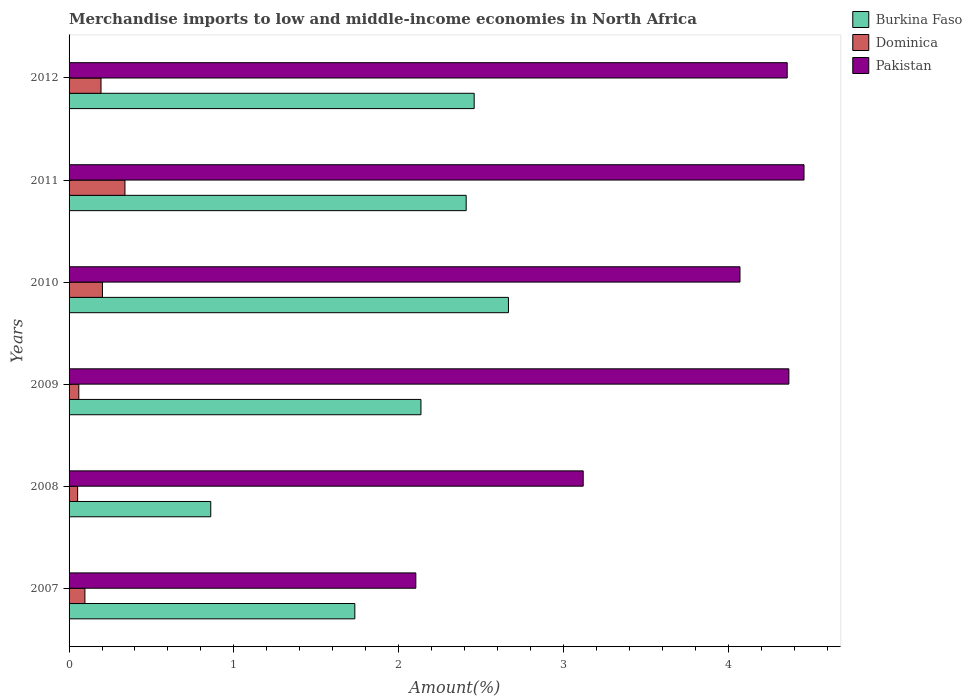How many different coloured bars are there?
Offer a terse response. 3. How many groups of bars are there?
Your answer should be compact. 6. Are the number of bars on each tick of the Y-axis equal?
Provide a succinct answer. Yes. What is the percentage of amount earned from merchandise imports in Pakistan in 2010?
Your response must be concise. 4.07. Across all years, what is the maximum percentage of amount earned from merchandise imports in Pakistan?
Provide a succinct answer. 4.46. Across all years, what is the minimum percentage of amount earned from merchandise imports in Burkina Faso?
Ensure brevity in your answer.  0.86. In which year was the percentage of amount earned from merchandise imports in Burkina Faso maximum?
Provide a succinct answer. 2010. In which year was the percentage of amount earned from merchandise imports in Burkina Faso minimum?
Provide a succinct answer. 2008. What is the total percentage of amount earned from merchandise imports in Burkina Faso in the graph?
Offer a very short reply. 12.26. What is the difference between the percentage of amount earned from merchandise imports in Pakistan in 2011 and that in 2012?
Provide a succinct answer. 0.1. What is the difference between the percentage of amount earned from merchandise imports in Burkina Faso in 2009 and the percentage of amount earned from merchandise imports in Pakistan in 2011?
Offer a very short reply. -2.32. What is the average percentage of amount earned from merchandise imports in Dominica per year?
Give a very brief answer. 0.16. In the year 2009, what is the difference between the percentage of amount earned from merchandise imports in Pakistan and percentage of amount earned from merchandise imports in Burkina Faso?
Make the answer very short. 2.23. In how many years, is the percentage of amount earned from merchandise imports in Dominica greater than 3.8 %?
Offer a terse response. 0. What is the ratio of the percentage of amount earned from merchandise imports in Dominica in 2008 to that in 2009?
Your response must be concise. 0.88. Is the difference between the percentage of amount earned from merchandise imports in Pakistan in 2008 and 2012 greater than the difference between the percentage of amount earned from merchandise imports in Burkina Faso in 2008 and 2012?
Keep it short and to the point. Yes. What is the difference between the highest and the second highest percentage of amount earned from merchandise imports in Burkina Faso?
Ensure brevity in your answer.  0.21. What is the difference between the highest and the lowest percentage of amount earned from merchandise imports in Dominica?
Give a very brief answer. 0.29. What does the 3rd bar from the top in 2007 represents?
Make the answer very short. Burkina Faso. How many bars are there?
Offer a very short reply. 18. Does the graph contain grids?
Your answer should be very brief. No. How many legend labels are there?
Provide a succinct answer. 3. How are the legend labels stacked?
Provide a short and direct response. Vertical. What is the title of the graph?
Ensure brevity in your answer.  Merchandise imports to low and middle-income economies in North Africa. What is the label or title of the X-axis?
Provide a short and direct response. Amount(%). What is the label or title of the Y-axis?
Offer a terse response. Years. What is the Amount(%) in Burkina Faso in 2007?
Ensure brevity in your answer.  1.73. What is the Amount(%) in Dominica in 2007?
Keep it short and to the point. 0.1. What is the Amount(%) in Pakistan in 2007?
Keep it short and to the point. 2.1. What is the Amount(%) in Burkina Faso in 2008?
Your answer should be very brief. 0.86. What is the Amount(%) of Dominica in 2008?
Provide a short and direct response. 0.05. What is the Amount(%) in Pakistan in 2008?
Give a very brief answer. 3.12. What is the Amount(%) of Burkina Faso in 2009?
Give a very brief answer. 2.14. What is the Amount(%) of Dominica in 2009?
Your response must be concise. 0.06. What is the Amount(%) in Pakistan in 2009?
Give a very brief answer. 4.37. What is the Amount(%) in Burkina Faso in 2010?
Keep it short and to the point. 2.67. What is the Amount(%) of Dominica in 2010?
Keep it short and to the point. 0.2. What is the Amount(%) of Pakistan in 2010?
Offer a very short reply. 4.07. What is the Amount(%) of Burkina Faso in 2011?
Offer a terse response. 2.41. What is the Amount(%) of Dominica in 2011?
Provide a succinct answer. 0.34. What is the Amount(%) in Pakistan in 2011?
Make the answer very short. 4.46. What is the Amount(%) in Burkina Faso in 2012?
Provide a succinct answer. 2.46. What is the Amount(%) of Dominica in 2012?
Ensure brevity in your answer.  0.19. What is the Amount(%) in Pakistan in 2012?
Provide a succinct answer. 4.36. Across all years, what is the maximum Amount(%) in Burkina Faso?
Provide a short and direct response. 2.67. Across all years, what is the maximum Amount(%) in Dominica?
Give a very brief answer. 0.34. Across all years, what is the maximum Amount(%) in Pakistan?
Give a very brief answer. 4.46. Across all years, what is the minimum Amount(%) in Burkina Faso?
Make the answer very short. 0.86. Across all years, what is the minimum Amount(%) in Dominica?
Your response must be concise. 0.05. Across all years, what is the minimum Amount(%) of Pakistan?
Provide a short and direct response. 2.1. What is the total Amount(%) in Burkina Faso in the graph?
Offer a terse response. 12.26. What is the total Amount(%) in Dominica in the graph?
Keep it short and to the point. 0.94. What is the total Amount(%) in Pakistan in the graph?
Your answer should be very brief. 22.48. What is the difference between the Amount(%) in Burkina Faso in 2007 and that in 2008?
Your response must be concise. 0.87. What is the difference between the Amount(%) in Dominica in 2007 and that in 2008?
Offer a terse response. 0.04. What is the difference between the Amount(%) of Pakistan in 2007 and that in 2008?
Your answer should be very brief. -1.02. What is the difference between the Amount(%) of Burkina Faso in 2007 and that in 2009?
Give a very brief answer. -0.4. What is the difference between the Amount(%) of Dominica in 2007 and that in 2009?
Your answer should be compact. 0.04. What is the difference between the Amount(%) in Pakistan in 2007 and that in 2009?
Your answer should be very brief. -2.26. What is the difference between the Amount(%) of Burkina Faso in 2007 and that in 2010?
Your answer should be compact. -0.93. What is the difference between the Amount(%) of Dominica in 2007 and that in 2010?
Provide a short and direct response. -0.11. What is the difference between the Amount(%) of Pakistan in 2007 and that in 2010?
Your response must be concise. -1.97. What is the difference between the Amount(%) of Burkina Faso in 2007 and that in 2011?
Your answer should be very brief. -0.68. What is the difference between the Amount(%) of Dominica in 2007 and that in 2011?
Your answer should be compact. -0.24. What is the difference between the Amount(%) in Pakistan in 2007 and that in 2011?
Make the answer very short. -2.36. What is the difference between the Amount(%) in Burkina Faso in 2007 and that in 2012?
Your answer should be very brief. -0.72. What is the difference between the Amount(%) of Dominica in 2007 and that in 2012?
Your response must be concise. -0.1. What is the difference between the Amount(%) in Pakistan in 2007 and that in 2012?
Provide a succinct answer. -2.25. What is the difference between the Amount(%) in Burkina Faso in 2008 and that in 2009?
Your answer should be compact. -1.28. What is the difference between the Amount(%) of Dominica in 2008 and that in 2009?
Your answer should be very brief. -0.01. What is the difference between the Amount(%) of Pakistan in 2008 and that in 2009?
Keep it short and to the point. -1.25. What is the difference between the Amount(%) in Burkina Faso in 2008 and that in 2010?
Offer a terse response. -1.81. What is the difference between the Amount(%) of Dominica in 2008 and that in 2010?
Provide a short and direct response. -0.15. What is the difference between the Amount(%) in Pakistan in 2008 and that in 2010?
Your answer should be compact. -0.95. What is the difference between the Amount(%) of Burkina Faso in 2008 and that in 2011?
Ensure brevity in your answer.  -1.55. What is the difference between the Amount(%) of Dominica in 2008 and that in 2011?
Give a very brief answer. -0.29. What is the difference between the Amount(%) of Pakistan in 2008 and that in 2011?
Your response must be concise. -1.34. What is the difference between the Amount(%) in Burkina Faso in 2008 and that in 2012?
Provide a succinct answer. -1.6. What is the difference between the Amount(%) of Dominica in 2008 and that in 2012?
Provide a short and direct response. -0.14. What is the difference between the Amount(%) of Pakistan in 2008 and that in 2012?
Your answer should be compact. -1.24. What is the difference between the Amount(%) of Burkina Faso in 2009 and that in 2010?
Your answer should be very brief. -0.53. What is the difference between the Amount(%) of Dominica in 2009 and that in 2010?
Provide a short and direct response. -0.14. What is the difference between the Amount(%) of Pakistan in 2009 and that in 2010?
Your response must be concise. 0.3. What is the difference between the Amount(%) in Burkina Faso in 2009 and that in 2011?
Your response must be concise. -0.27. What is the difference between the Amount(%) in Dominica in 2009 and that in 2011?
Provide a succinct answer. -0.28. What is the difference between the Amount(%) in Pakistan in 2009 and that in 2011?
Keep it short and to the point. -0.09. What is the difference between the Amount(%) of Burkina Faso in 2009 and that in 2012?
Provide a short and direct response. -0.32. What is the difference between the Amount(%) in Dominica in 2009 and that in 2012?
Give a very brief answer. -0.13. What is the difference between the Amount(%) of Pakistan in 2009 and that in 2012?
Keep it short and to the point. 0.01. What is the difference between the Amount(%) in Burkina Faso in 2010 and that in 2011?
Provide a succinct answer. 0.26. What is the difference between the Amount(%) in Dominica in 2010 and that in 2011?
Ensure brevity in your answer.  -0.14. What is the difference between the Amount(%) of Pakistan in 2010 and that in 2011?
Ensure brevity in your answer.  -0.39. What is the difference between the Amount(%) in Burkina Faso in 2010 and that in 2012?
Ensure brevity in your answer.  0.21. What is the difference between the Amount(%) in Dominica in 2010 and that in 2012?
Offer a terse response. 0.01. What is the difference between the Amount(%) of Pakistan in 2010 and that in 2012?
Your answer should be compact. -0.29. What is the difference between the Amount(%) in Burkina Faso in 2011 and that in 2012?
Offer a terse response. -0.05. What is the difference between the Amount(%) in Dominica in 2011 and that in 2012?
Your answer should be compact. 0.15. What is the difference between the Amount(%) in Pakistan in 2011 and that in 2012?
Provide a succinct answer. 0.1. What is the difference between the Amount(%) in Burkina Faso in 2007 and the Amount(%) in Dominica in 2008?
Offer a very short reply. 1.68. What is the difference between the Amount(%) in Burkina Faso in 2007 and the Amount(%) in Pakistan in 2008?
Offer a terse response. -1.39. What is the difference between the Amount(%) of Dominica in 2007 and the Amount(%) of Pakistan in 2008?
Your answer should be compact. -3.02. What is the difference between the Amount(%) in Burkina Faso in 2007 and the Amount(%) in Dominica in 2009?
Your answer should be compact. 1.67. What is the difference between the Amount(%) of Burkina Faso in 2007 and the Amount(%) of Pakistan in 2009?
Your response must be concise. -2.63. What is the difference between the Amount(%) in Dominica in 2007 and the Amount(%) in Pakistan in 2009?
Provide a succinct answer. -4.27. What is the difference between the Amount(%) in Burkina Faso in 2007 and the Amount(%) in Dominica in 2010?
Provide a short and direct response. 1.53. What is the difference between the Amount(%) of Burkina Faso in 2007 and the Amount(%) of Pakistan in 2010?
Offer a terse response. -2.34. What is the difference between the Amount(%) in Dominica in 2007 and the Amount(%) in Pakistan in 2010?
Offer a very short reply. -3.98. What is the difference between the Amount(%) of Burkina Faso in 2007 and the Amount(%) of Dominica in 2011?
Your answer should be compact. 1.39. What is the difference between the Amount(%) in Burkina Faso in 2007 and the Amount(%) in Pakistan in 2011?
Make the answer very short. -2.73. What is the difference between the Amount(%) in Dominica in 2007 and the Amount(%) in Pakistan in 2011?
Give a very brief answer. -4.36. What is the difference between the Amount(%) in Burkina Faso in 2007 and the Amount(%) in Dominica in 2012?
Provide a succinct answer. 1.54. What is the difference between the Amount(%) in Burkina Faso in 2007 and the Amount(%) in Pakistan in 2012?
Give a very brief answer. -2.62. What is the difference between the Amount(%) in Dominica in 2007 and the Amount(%) in Pakistan in 2012?
Your answer should be compact. -4.26. What is the difference between the Amount(%) of Burkina Faso in 2008 and the Amount(%) of Dominica in 2009?
Give a very brief answer. 0.8. What is the difference between the Amount(%) of Burkina Faso in 2008 and the Amount(%) of Pakistan in 2009?
Keep it short and to the point. -3.51. What is the difference between the Amount(%) in Dominica in 2008 and the Amount(%) in Pakistan in 2009?
Keep it short and to the point. -4.32. What is the difference between the Amount(%) of Burkina Faso in 2008 and the Amount(%) of Dominica in 2010?
Your answer should be very brief. 0.66. What is the difference between the Amount(%) in Burkina Faso in 2008 and the Amount(%) in Pakistan in 2010?
Give a very brief answer. -3.21. What is the difference between the Amount(%) in Dominica in 2008 and the Amount(%) in Pakistan in 2010?
Your answer should be very brief. -4.02. What is the difference between the Amount(%) in Burkina Faso in 2008 and the Amount(%) in Dominica in 2011?
Ensure brevity in your answer.  0.52. What is the difference between the Amount(%) in Burkina Faso in 2008 and the Amount(%) in Pakistan in 2011?
Your answer should be compact. -3.6. What is the difference between the Amount(%) of Dominica in 2008 and the Amount(%) of Pakistan in 2011?
Your answer should be very brief. -4.41. What is the difference between the Amount(%) in Burkina Faso in 2008 and the Amount(%) in Dominica in 2012?
Make the answer very short. 0.67. What is the difference between the Amount(%) in Burkina Faso in 2008 and the Amount(%) in Pakistan in 2012?
Offer a very short reply. -3.5. What is the difference between the Amount(%) of Dominica in 2008 and the Amount(%) of Pakistan in 2012?
Your answer should be very brief. -4.31. What is the difference between the Amount(%) of Burkina Faso in 2009 and the Amount(%) of Dominica in 2010?
Offer a terse response. 1.93. What is the difference between the Amount(%) in Burkina Faso in 2009 and the Amount(%) in Pakistan in 2010?
Your response must be concise. -1.94. What is the difference between the Amount(%) in Dominica in 2009 and the Amount(%) in Pakistan in 2010?
Your answer should be very brief. -4.01. What is the difference between the Amount(%) of Burkina Faso in 2009 and the Amount(%) of Dominica in 2011?
Provide a short and direct response. 1.8. What is the difference between the Amount(%) in Burkina Faso in 2009 and the Amount(%) in Pakistan in 2011?
Your response must be concise. -2.32. What is the difference between the Amount(%) of Dominica in 2009 and the Amount(%) of Pakistan in 2011?
Ensure brevity in your answer.  -4.4. What is the difference between the Amount(%) of Burkina Faso in 2009 and the Amount(%) of Dominica in 2012?
Offer a very short reply. 1.94. What is the difference between the Amount(%) in Burkina Faso in 2009 and the Amount(%) in Pakistan in 2012?
Provide a short and direct response. -2.22. What is the difference between the Amount(%) of Dominica in 2009 and the Amount(%) of Pakistan in 2012?
Your answer should be very brief. -4.3. What is the difference between the Amount(%) in Burkina Faso in 2010 and the Amount(%) in Dominica in 2011?
Keep it short and to the point. 2.33. What is the difference between the Amount(%) in Burkina Faso in 2010 and the Amount(%) in Pakistan in 2011?
Give a very brief answer. -1.79. What is the difference between the Amount(%) in Dominica in 2010 and the Amount(%) in Pakistan in 2011?
Make the answer very short. -4.26. What is the difference between the Amount(%) in Burkina Faso in 2010 and the Amount(%) in Dominica in 2012?
Provide a succinct answer. 2.47. What is the difference between the Amount(%) of Burkina Faso in 2010 and the Amount(%) of Pakistan in 2012?
Make the answer very short. -1.69. What is the difference between the Amount(%) in Dominica in 2010 and the Amount(%) in Pakistan in 2012?
Ensure brevity in your answer.  -4.16. What is the difference between the Amount(%) of Burkina Faso in 2011 and the Amount(%) of Dominica in 2012?
Offer a very short reply. 2.22. What is the difference between the Amount(%) in Burkina Faso in 2011 and the Amount(%) in Pakistan in 2012?
Your response must be concise. -1.95. What is the difference between the Amount(%) in Dominica in 2011 and the Amount(%) in Pakistan in 2012?
Your response must be concise. -4.02. What is the average Amount(%) of Burkina Faso per year?
Keep it short and to the point. 2.04. What is the average Amount(%) in Dominica per year?
Provide a short and direct response. 0.16. What is the average Amount(%) of Pakistan per year?
Provide a succinct answer. 3.75. In the year 2007, what is the difference between the Amount(%) of Burkina Faso and Amount(%) of Dominica?
Offer a very short reply. 1.64. In the year 2007, what is the difference between the Amount(%) in Burkina Faso and Amount(%) in Pakistan?
Your answer should be very brief. -0.37. In the year 2007, what is the difference between the Amount(%) in Dominica and Amount(%) in Pakistan?
Give a very brief answer. -2.01. In the year 2008, what is the difference between the Amount(%) in Burkina Faso and Amount(%) in Dominica?
Provide a succinct answer. 0.81. In the year 2008, what is the difference between the Amount(%) of Burkina Faso and Amount(%) of Pakistan?
Ensure brevity in your answer.  -2.26. In the year 2008, what is the difference between the Amount(%) of Dominica and Amount(%) of Pakistan?
Ensure brevity in your answer.  -3.07. In the year 2009, what is the difference between the Amount(%) in Burkina Faso and Amount(%) in Dominica?
Provide a succinct answer. 2.08. In the year 2009, what is the difference between the Amount(%) in Burkina Faso and Amount(%) in Pakistan?
Provide a succinct answer. -2.23. In the year 2009, what is the difference between the Amount(%) of Dominica and Amount(%) of Pakistan?
Ensure brevity in your answer.  -4.31. In the year 2010, what is the difference between the Amount(%) in Burkina Faso and Amount(%) in Dominica?
Make the answer very short. 2.46. In the year 2010, what is the difference between the Amount(%) in Burkina Faso and Amount(%) in Pakistan?
Your response must be concise. -1.41. In the year 2010, what is the difference between the Amount(%) of Dominica and Amount(%) of Pakistan?
Your response must be concise. -3.87. In the year 2011, what is the difference between the Amount(%) in Burkina Faso and Amount(%) in Dominica?
Your answer should be very brief. 2.07. In the year 2011, what is the difference between the Amount(%) of Burkina Faso and Amount(%) of Pakistan?
Your response must be concise. -2.05. In the year 2011, what is the difference between the Amount(%) of Dominica and Amount(%) of Pakistan?
Ensure brevity in your answer.  -4.12. In the year 2012, what is the difference between the Amount(%) of Burkina Faso and Amount(%) of Dominica?
Your answer should be compact. 2.26. In the year 2012, what is the difference between the Amount(%) in Burkina Faso and Amount(%) in Pakistan?
Your answer should be compact. -1.9. In the year 2012, what is the difference between the Amount(%) in Dominica and Amount(%) in Pakistan?
Your response must be concise. -4.16. What is the ratio of the Amount(%) of Burkina Faso in 2007 to that in 2008?
Offer a very short reply. 2.02. What is the ratio of the Amount(%) in Dominica in 2007 to that in 2008?
Your answer should be compact. 1.85. What is the ratio of the Amount(%) in Pakistan in 2007 to that in 2008?
Provide a succinct answer. 0.67. What is the ratio of the Amount(%) in Burkina Faso in 2007 to that in 2009?
Make the answer very short. 0.81. What is the ratio of the Amount(%) of Dominica in 2007 to that in 2009?
Your answer should be compact. 1.63. What is the ratio of the Amount(%) in Pakistan in 2007 to that in 2009?
Make the answer very short. 0.48. What is the ratio of the Amount(%) of Burkina Faso in 2007 to that in 2010?
Offer a very short reply. 0.65. What is the ratio of the Amount(%) of Dominica in 2007 to that in 2010?
Ensure brevity in your answer.  0.47. What is the ratio of the Amount(%) of Pakistan in 2007 to that in 2010?
Provide a succinct answer. 0.52. What is the ratio of the Amount(%) in Burkina Faso in 2007 to that in 2011?
Your answer should be very brief. 0.72. What is the ratio of the Amount(%) of Dominica in 2007 to that in 2011?
Offer a very short reply. 0.28. What is the ratio of the Amount(%) in Pakistan in 2007 to that in 2011?
Your response must be concise. 0.47. What is the ratio of the Amount(%) of Burkina Faso in 2007 to that in 2012?
Keep it short and to the point. 0.71. What is the ratio of the Amount(%) in Dominica in 2007 to that in 2012?
Provide a short and direct response. 0.5. What is the ratio of the Amount(%) of Pakistan in 2007 to that in 2012?
Provide a succinct answer. 0.48. What is the ratio of the Amount(%) in Burkina Faso in 2008 to that in 2009?
Your response must be concise. 0.4. What is the ratio of the Amount(%) of Dominica in 2008 to that in 2009?
Provide a succinct answer. 0.88. What is the ratio of the Amount(%) in Pakistan in 2008 to that in 2009?
Ensure brevity in your answer.  0.71. What is the ratio of the Amount(%) of Burkina Faso in 2008 to that in 2010?
Provide a succinct answer. 0.32. What is the ratio of the Amount(%) in Dominica in 2008 to that in 2010?
Offer a terse response. 0.26. What is the ratio of the Amount(%) of Pakistan in 2008 to that in 2010?
Make the answer very short. 0.77. What is the ratio of the Amount(%) of Burkina Faso in 2008 to that in 2011?
Your response must be concise. 0.36. What is the ratio of the Amount(%) of Dominica in 2008 to that in 2011?
Keep it short and to the point. 0.15. What is the ratio of the Amount(%) in Pakistan in 2008 to that in 2011?
Provide a succinct answer. 0.7. What is the ratio of the Amount(%) of Burkina Faso in 2008 to that in 2012?
Give a very brief answer. 0.35. What is the ratio of the Amount(%) in Dominica in 2008 to that in 2012?
Offer a terse response. 0.27. What is the ratio of the Amount(%) of Pakistan in 2008 to that in 2012?
Offer a very short reply. 0.72. What is the ratio of the Amount(%) in Burkina Faso in 2009 to that in 2010?
Keep it short and to the point. 0.8. What is the ratio of the Amount(%) of Dominica in 2009 to that in 2010?
Offer a terse response. 0.29. What is the ratio of the Amount(%) in Pakistan in 2009 to that in 2010?
Your response must be concise. 1.07. What is the ratio of the Amount(%) in Burkina Faso in 2009 to that in 2011?
Keep it short and to the point. 0.89. What is the ratio of the Amount(%) in Dominica in 2009 to that in 2011?
Your answer should be compact. 0.17. What is the ratio of the Amount(%) in Pakistan in 2009 to that in 2011?
Offer a very short reply. 0.98. What is the ratio of the Amount(%) of Burkina Faso in 2009 to that in 2012?
Your answer should be very brief. 0.87. What is the ratio of the Amount(%) in Dominica in 2009 to that in 2012?
Offer a very short reply. 0.3. What is the ratio of the Amount(%) of Burkina Faso in 2010 to that in 2011?
Your answer should be very brief. 1.11. What is the ratio of the Amount(%) of Dominica in 2010 to that in 2011?
Give a very brief answer. 0.6. What is the ratio of the Amount(%) in Pakistan in 2010 to that in 2011?
Your answer should be very brief. 0.91. What is the ratio of the Amount(%) of Burkina Faso in 2010 to that in 2012?
Keep it short and to the point. 1.08. What is the ratio of the Amount(%) in Dominica in 2010 to that in 2012?
Your answer should be very brief. 1.05. What is the ratio of the Amount(%) in Pakistan in 2010 to that in 2012?
Give a very brief answer. 0.93. What is the ratio of the Amount(%) in Burkina Faso in 2011 to that in 2012?
Your response must be concise. 0.98. What is the ratio of the Amount(%) of Dominica in 2011 to that in 2012?
Provide a succinct answer. 1.75. What is the ratio of the Amount(%) in Pakistan in 2011 to that in 2012?
Offer a very short reply. 1.02. What is the difference between the highest and the second highest Amount(%) of Burkina Faso?
Give a very brief answer. 0.21. What is the difference between the highest and the second highest Amount(%) of Dominica?
Make the answer very short. 0.14. What is the difference between the highest and the second highest Amount(%) in Pakistan?
Your answer should be compact. 0.09. What is the difference between the highest and the lowest Amount(%) of Burkina Faso?
Keep it short and to the point. 1.81. What is the difference between the highest and the lowest Amount(%) of Dominica?
Provide a succinct answer. 0.29. What is the difference between the highest and the lowest Amount(%) in Pakistan?
Your answer should be compact. 2.36. 